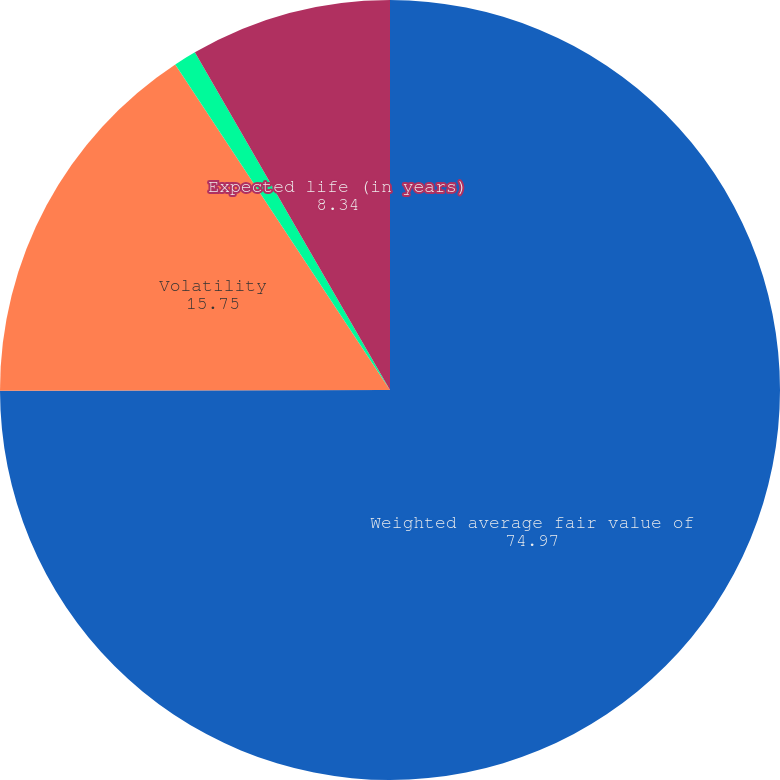Convert chart. <chart><loc_0><loc_0><loc_500><loc_500><pie_chart><fcel>Weighted average fair value of<fcel>Volatility<fcel>Risk-free interest rate<fcel>Expected life (in years)<nl><fcel>74.97%<fcel>15.75%<fcel>0.94%<fcel>8.34%<nl></chart> 